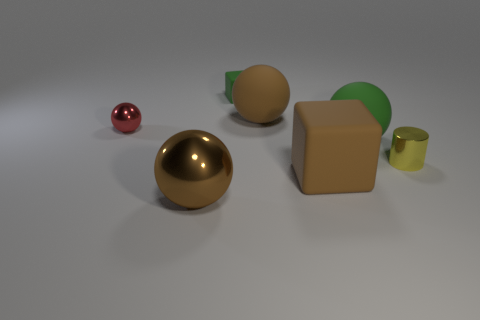Subtract all large spheres. How many spheres are left? 1 Add 2 big brown shiny things. How many objects exist? 9 Subtract all purple cylinders. How many brown spheres are left? 2 Subtract 1 cubes. How many cubes are left? 1 Subtract all brown cubes. How many cubes are left? 1 Subtract all cyan cylinders. Subtract all yellow blocks. How many cylinders are left? 1 Subtract all big brown balls. Subtract all big green rubber things. How many objects are left? 4 Add 2 brown matte balls. How many brown matte balls are left? 3 Add 7 gray matte cylinders. How many gray matte cylinders exist? 7 Subtract 0 cyan cylinders. How many objects are left? 7 